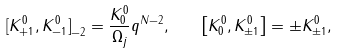Convert formula to latex. <formula><loc_0><loc_0><loc_500><loc_500>[ K _ { + 1 } ^ { 0 } { , K _ { - 1 } ^ { 0 } ] } _ { - 2 } = \frac { K _ { 0 } ^ { 0 } } { \Omega _ { j } } q ^ { N { - 2 } } , \quad \left [ K _ { 0 } ^ { 0 } , K _ { \pm 1 } ^ { 0 } \right ] = \pm K _ { \pm 1 } ^ { 0 } ,</formula> 